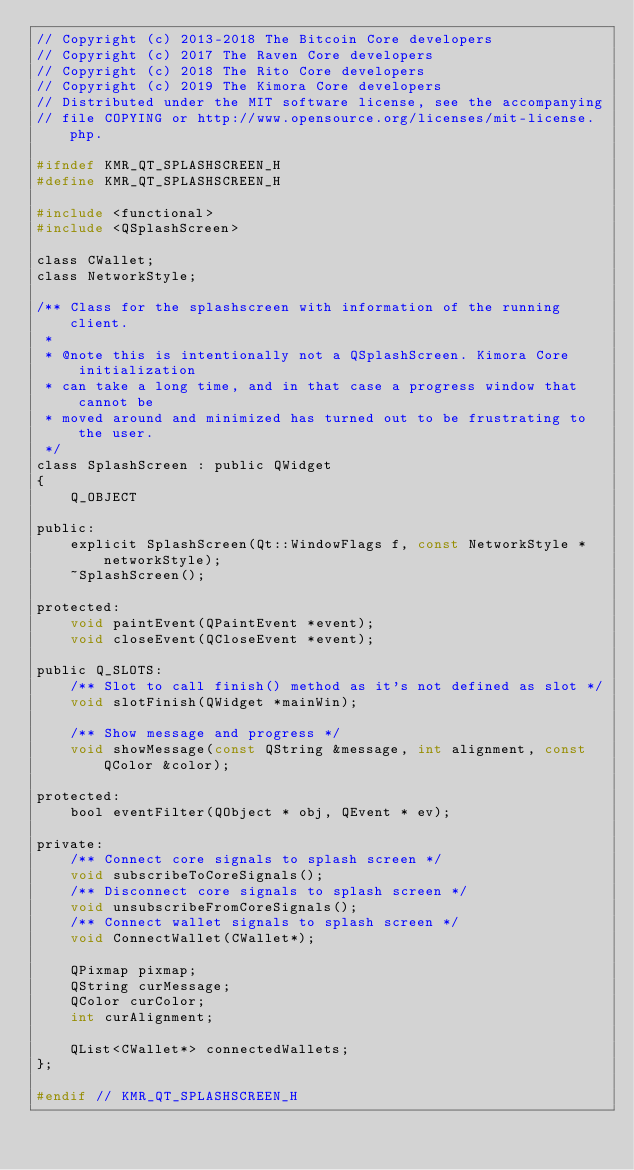Convert code to text. <code><loc_0><loc_0><loc_500><loc_500><_C_>// Copyright (c) 2013-2018 The Bitcoin Core developers
// Copyright (c) 2017 The Raven Core developers
// Copyright (c) 2018 The Rito Core developers
// Copyright (c) 2019 The Kimora Core developers
// Distributed under the MIT software license, see the accompanying
// file COPYING or http://www.opensource.org/licenses/mit-license.php.

#ifndef KMR_QT_SPLASHSCREEN_H
#define KMR_QT_SPLASHSCREEN_H

#include <functional>
#include <QSplashScreen>

class CWallet;
class NetworkStyle;

/** Class for the splashscreen with information of the running client.
 *
 * @note this is intentionally not a QSplashScreen. Kimora Core initialization
 * can take a long time, and in that case a progress window that cannot be
 * moved around and minimized has turned out to be frustrating to the user.
 */
class SplashScreen : public QWidget
{
    Q_OBJECT

public:
    explicit SplashScreen(Qt::WindowFlags f, const NetworkStyle *networkStyle);
    ~SplashScreen();

protected:
    void paintEvent(QPaintEvent *event);
    void closeEvent(QCloseEvent *event);

public Q_SLOTS:
    /** Slot to call finish() method as it's not defined as slot */
    void slotFinish(QWidget *mainWin);

    /** Show message and progress */
    void showMessage(const QString &message, int alignment, const QColor &color);

protected:
    bool eventFilter(QObject * obj, QEvent * ev);

private:
    /** Connect core signals to splash screen */
    void subscribeToCoreSignals();
    /** Disconnect core signals to splash screen */
    void unsubscribeFromCoreSignals();
    /** Connect wallet signals to splash screen */
    void ConnectWallet(CWallet*);

    QPixmap pixmap;
    QString curMessage;
    QColor curColor;
    int curAlignment;

    QList<CWallet*> connectedWallets;
};

#endif // KMR_QT_SPLASHSCREEN_H
</code> 